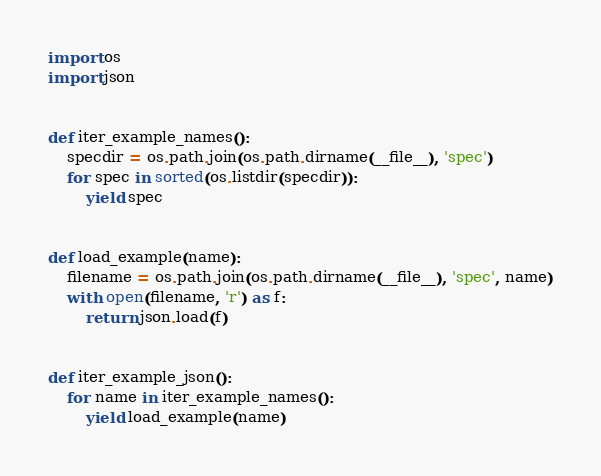Convert code to text. <code><loc_0><loc_0><loc_500><loc_500><_Python_>import os
import json


def iter_example_names():
    specdir = os.path.join(os.path.dirname(__file__), 'spec')
    for spec in sorted(os.listdir(specdir)):
        yield spec


def load_example(name):
    filename = os.path.join(os.path.dirname(__file__), 'spec', name)
    with open(filename, 'r') as f:
        return json.load(f)


def iter_example_json():
    for name in iter_example_names():
        yield load_example(name)
</code> 